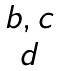<formula> <loc_0><loc_0><loc_500><loc_500>\begin{matrix} { b , c } \\ { d } \end{matrix}</formula> 